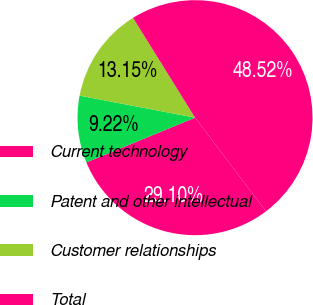Convert chart to OTSL. <chart><loc_0><loc_0><loc_500><loc_500><pie_chart><fcel>Current technology<fcel>Patent and other intellectual<fcel>Customer relationships<fcel>Total<nl><fcel>29.1%<fcel>9.22%<fcel>13.15%<fcel>48.52%<nl></chart> 